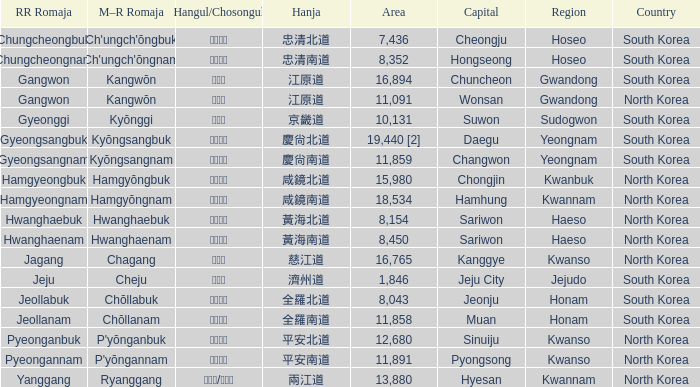Which capital features a hangul of 경상남도? Changwon. 